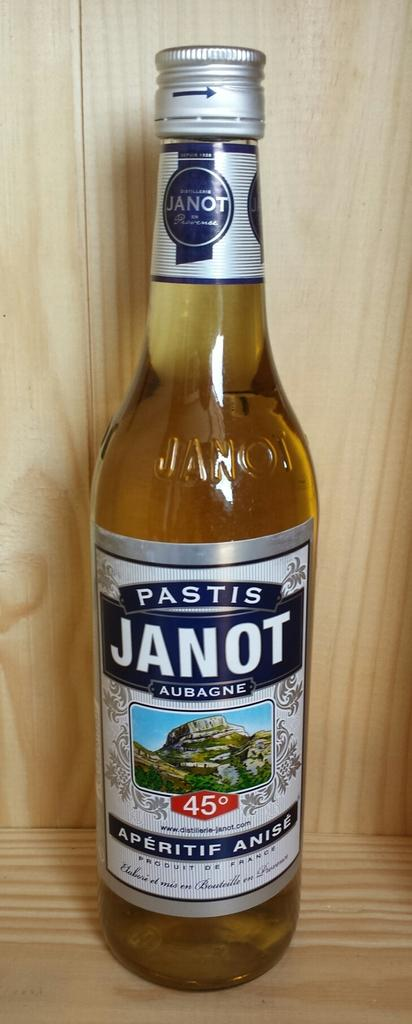<image>
Present a compact description of the photo's key features. a bottle that has the name Janot written on it 